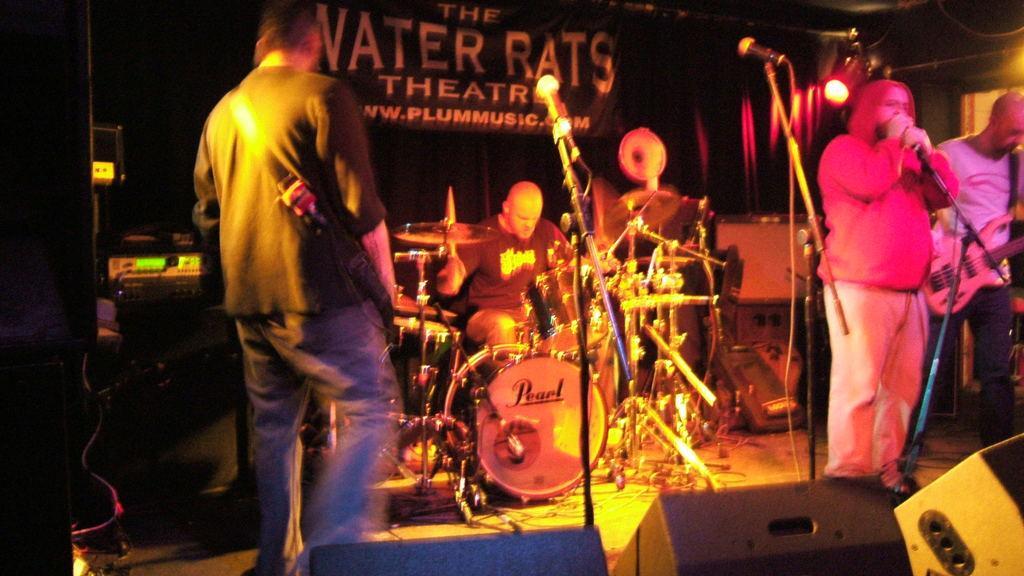Please provide a concise description of this image. Left side of image there is a person standing. Right side of image there are two persons standing. One is holding a guitar and other one is wearing pink shirt and pant is holding a mike. In middle there's a musical instrument , behind which a person is playing it by sitting. Background there is a banner naming water raterats theater. Left side there is a electrical instrument. 